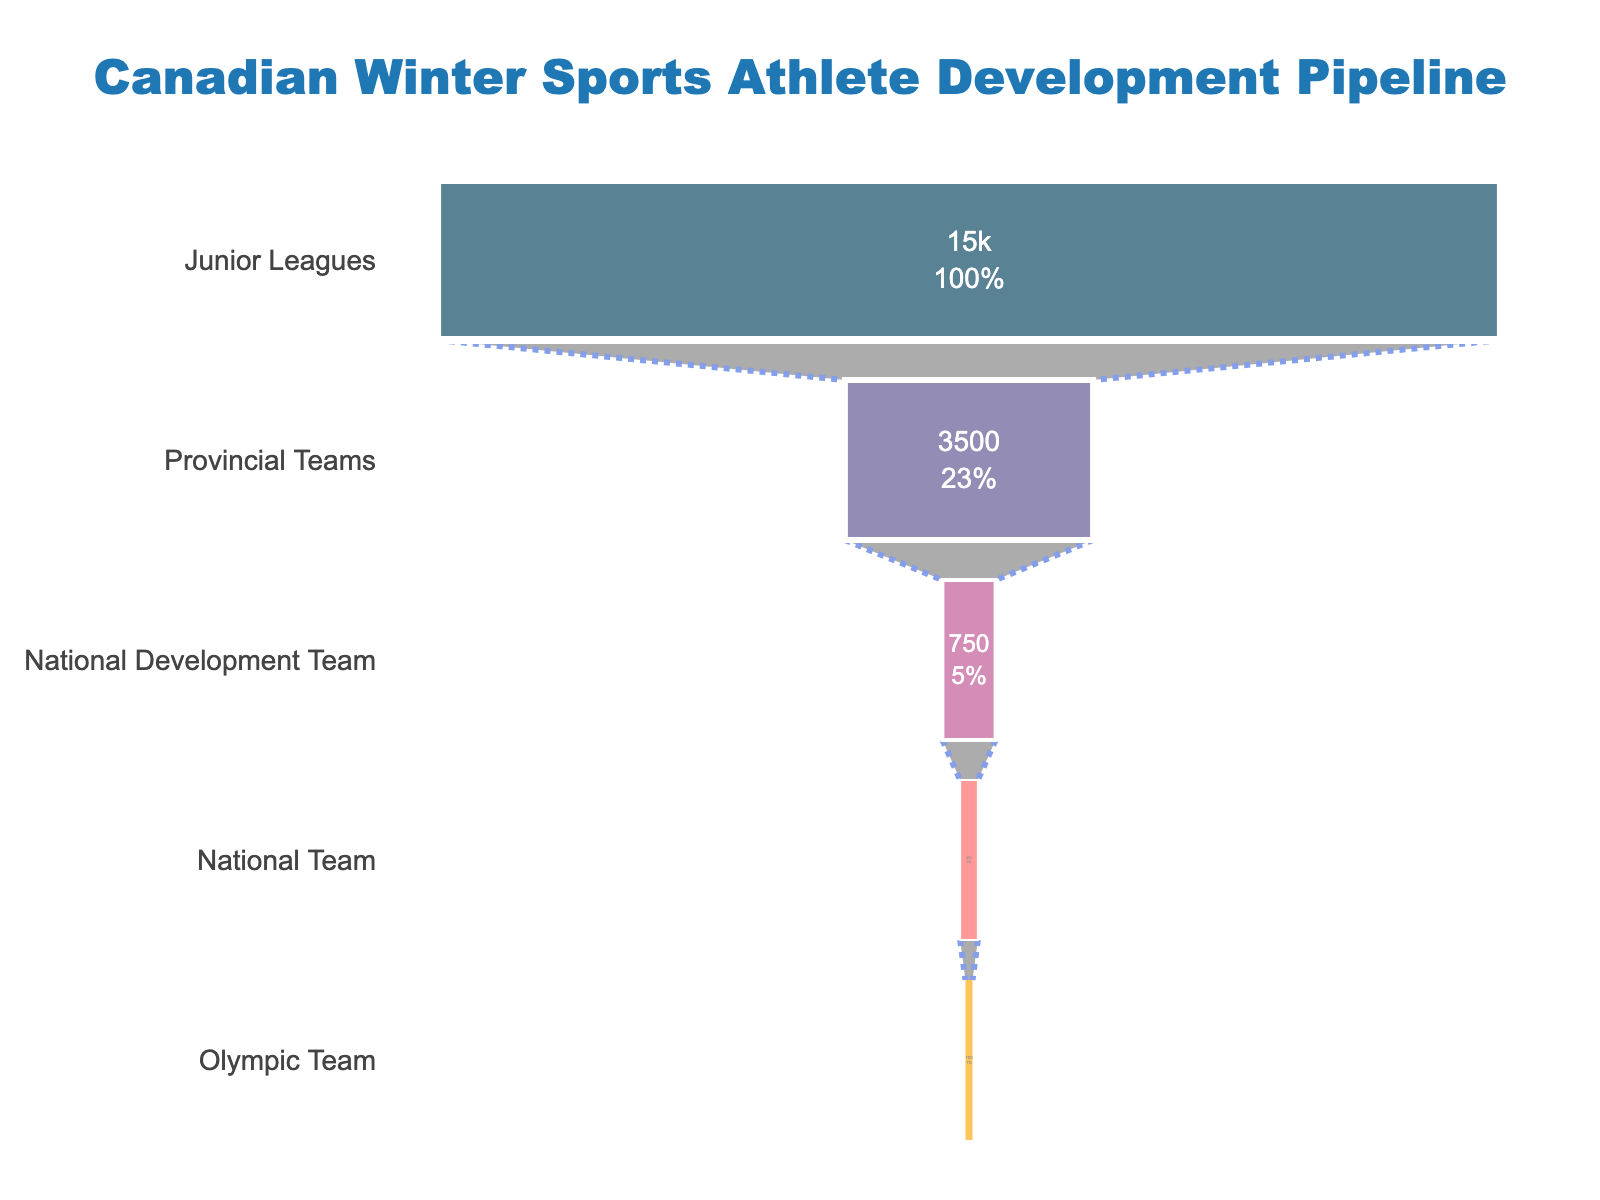What's the title of the funnel chart? The title is usually located at the top center of the chart. Here, it clearly reads: "Canadian Winter Sports Athlete Development Pipeline".
Answer: Canadian Winter Sports Athlete Development Pipeline What is the percentage of athletes progressing from the Junior Leagues to the Provincial Teams? First, find the number of athletes in Junior Leagues (15,000) and Provincial Teams (3,500). The percentage progressing is calculated as (3,500 / 15,000) * 100.
Answer: 23.33% How many stages are shown in the development pipeline? The stages are listed vertically in the funnel chart, representing the levels from Junior Leagues to Olympic Team. Counting these stages gives us the total number.
Answer: 5 Which stage has the steepest drop in the number of athletes? By examining the numerical drop between each consecutive stage, the steepest drop can be identified. The largest drop is from Junior Leagues (15,000) to Provincial Teams (3,500).
Answer: Junior Leagues to Provincial Teams What proportion of athletes reach the Olympic Team out of those who make it to the National Team? The number of athletes in the National Team is 250, and the Olympic Team has 100 athletes. The proportion is (100 / 250) * 100.
Answer: 40% How many athletes in total are represented in the entire funnel? The total is simply the sum of athletes at each stage of the funnel. Adding 15,000 (Junior Leagues) + 3,500 (Provincial Teams) + 750 (National Development Team) + 250 (National Team) + 100 (Olympic Team) gives the total number of athletes initially counted. However, since this is a funnel, overlapping counts should not be summed directly.
Answer: Data overlap; sum not meaningful What is the color used to represent the National Development Team stage? The funnel uses distinct colors for each stage. The National Development Team is represented by the third color in the sequence. Checking against the color descriptions, it is "#bc5090". Visually, it's a shade of purple.
Answer: Purple What is the decrease in number of athletes from the National Development Team to the National Team? The number of athletes in the National Development Team is 750, and in the National Team, it is 250. The decrease is calculated as 750 - 250.
Answer: 500 Between which two stages is the percentage of attrition the highest? To find the highest attrition percentage, calculate the percentage drop between each consecutive pair of stages. The largest percentage drop is between Junior Leagues (15000) and Provincial Teams (3500), which is ((15000 - 3500) / 15000) * 100.
Answer: Junior Leagues to Provincial Teams How much smaller (in percentage) is the Olympic Team compared to the Junior Leagues? The number of athletes in Junior Leagues is 15,000 and in the Olympic Team it is 100. The decrease in percentage is calculated as ((15000 - 100) / 15000) * 100.
Answer: 99.33% 